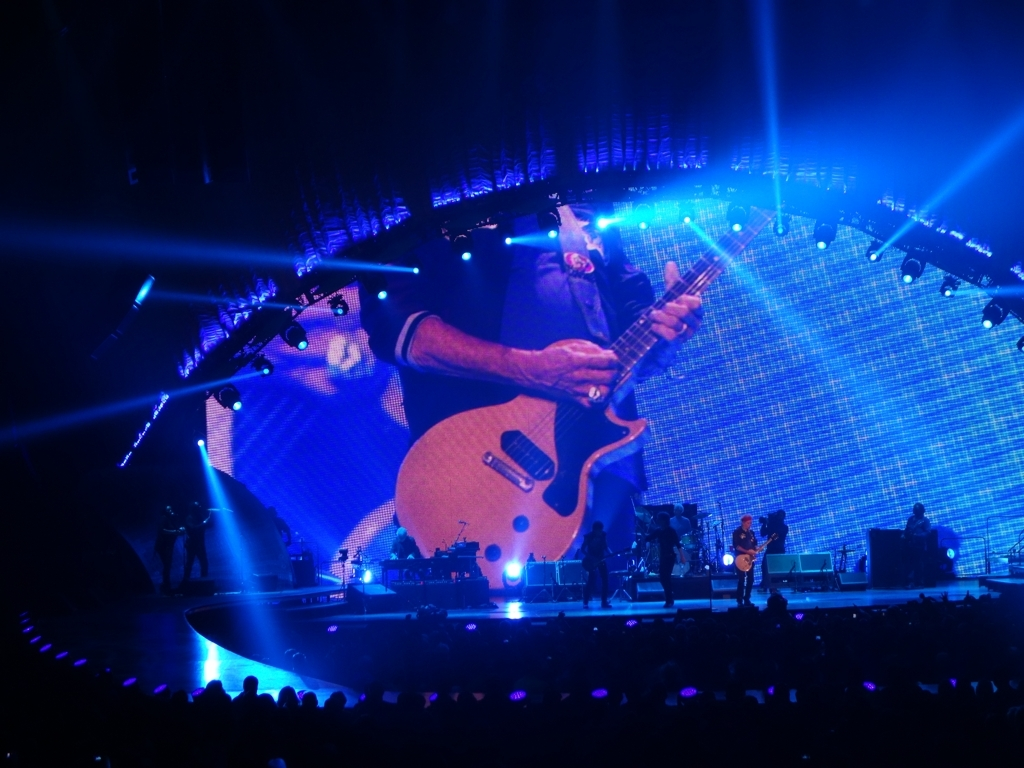Is the image of poor quality? The image displays a concert scene which appears to be of satisfactory quality, capturing clear stage lighting and the performer's actions without any significant visual distortions or blurriness that would typically indicate poor quality. 